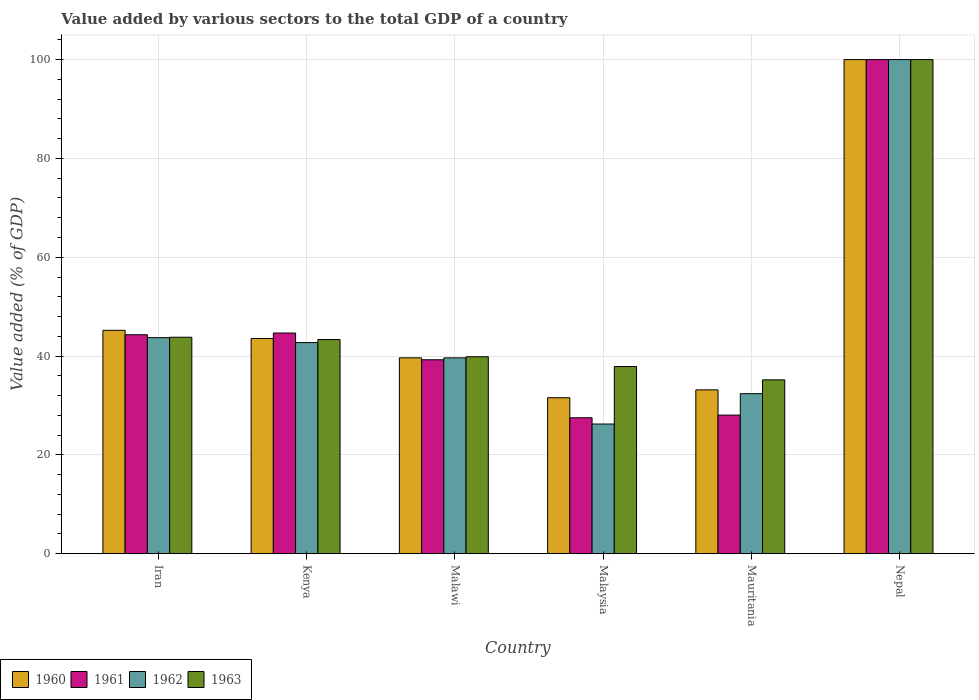How many different coloured bars are there?
Provide a short and direct response. 4. Are the number of bars on each tick of the X-axis equal?
Your answer should be very brief. Yes. What is the label of the 2nd group of bars from the left?
Give a very brief answer. Kenya. In how many cases, is the number of bars for a given country not equal to the number of legend labels?
Offer a terse response. 0. What is the value added by various sectors to the total GDP in 1960 in Mauritania?
Ensure brevity in your answer.  33.17. Across all countries, what is the maximum value added by various sectors to the total GDP in 1960?
Make the answer very short. 100. Across all countries, what is the minimum value added by various sectors to the total GDP in 1960?
Ensure brevity in your answer.  31.57. In which country was the value added by various sectors to the total GDP in 1963 maximum?
Your response must be concise. Nepal. In which country was the value added by various sectors to the total GDP in 1961 minimum?
Your response must be concise. Malaysia. What is the total value added by various sectors to the total GDP in 1961 in the graph?
Give a very brief answer. 283.82. What is the difference between the value added by various sectors to the total GDP in 1962 in Kenya and that in Mauritania?
Give a very brief answer. 10.34. What is the difference between the value added by various sectors to the total GDP in 1960 in Iran and the value added by various sectors to the total GDP in 1962 in Nepal?
Offer a terse response. -54.79. What is the average value added by various sectors to the total GDP in 1961 per country?
Give a very brief answer. 47.3. What is the difference between the value added by various sectors to the total GDP of/in 1962 and value added by various sectors to the total GDP of/in 1963 in Iran?
Offer a terse response. -0.08. What is the ratio of the value added by various sectors to the total GDP in 1962 in Iran to that in Malaysia?
Provide a short and direct response. 1.67. Is the difference between the value added by various sectors to the total GDP in 1962 in Kenya and Mauritania greater than the difference between the value added by various sectors to the total GDP in 1963 in Kenya and Mauritania?
Your response must be concise. Yes. What is the difference between the highest and the second highest value added by various sectors to the total GDP in 1963?
Provide a short and direct response. -0.46. What is the difference between the highest and the lowest value added by various sectors to the total GDP in 1962?
Give a very brief answer. 73.75. In how many countries, is the value added by various sectors to the total GDP in 1963 greater than the average value added by various sectors to the total GDP in 1963 taken over all countries?
Provide a short and direct response. 1. What does the 2nd bar from the right in Nepal represents?
Your answer should be very brief. 1962. Are all the bars in the graph horizontal?
Keep it short and to the point. No. Does the graph contain any zero values?
Give a very brief answer. No. Does the graph contain grids?
Give a very brief answer. Yes. Where does the legend appear in the graph?
Make the answer very short. Bottom left. What is the title of the graph?
Your response must be concise. Value added by various sectors to the total GDP of a country. Does "1962" appear as one of the legend labels in the graph?
Make the answer very short. Yes. What is the label or title of the Y-axis?
Offer a very short reply. Value added (% of GDP). What is the Value added (% of GDP) of 1960 in Iran?
Your answer should be very brief. 45.21. What is the Value added (% of GDP) in 1961 in Iran?
Ensure brevity in your answer.  44.32. What is the Value added (% of GDP) of 1962 in Iran?
Give a very brief answer. 43.73. What is the Value added (% of GDP) in 1963 in Iran?
Offer a terse response. 43.81. What is the Value added (% of GDP) of 1960 in Kenya?
Provide a short and direct response. 43.56. What is the Value added (% of GDP) of 1961 in Kenya?
Your answer should be compact. 44.67. What is the Value added (% of GDP) of 1962 in Kenya?
Provide a short and direct response. 42.73. What is the Value added (% of GDP) of 1963 in Kenya?
Your answer should be compact. 43.35. What is the Value added (% of GDP) of 1960 in Malawi?
Give a very brief answer. 39.64. What is the Value added (% of GDP) in 1961 in Malawi?
Your answer should be compact. 39.25. What is the Value added (% of GDP) in 1962 in Malawi?
Your response must be concise. 39.64. What is the Value added (% of GDP) in 1963 in Malawi?
Offer a terse response. 39.86. What is the Value added (% of GDP) in 1960 in Malaysia?
Your response must be concise. 31.57. What is the Value added (% of GDP) of 1961 in Malaysia?
Your answer should be very brief. 27.52. What is the Value added (% of GDP) in 1962 in Malaysia?
Your response must be concise. 26.25. What is the Value added (% of GDP) in 1963 in Malaysia?
Make the answer very short. 37.89. What is the Value added (% of GDP) of 1960 in Mauritania?
Your answer should be compact. 33.17. What is the Value added (% of GDP) of 1961 in Mauritania?
Offer a terse response. 28.06. What is the Value added (% of GDP) of 1962 in Mauritania?
Your response must be concise. 32.4. What is the Value added (% of GDP) of 1963 in Mauritania?
Offer a very short reply. 35.19. What is the Value added (% of GDP) in 1962 in Nepal?
Your answer should be very brief. 100. Across all countries, what is the maximum Value added (% of GDP) in 1960?
Make the answer very short. 100. Across all countries, what is the maximum Value added (% of GDP) in 1961?
Keep it short and to the point. 100. Across all countries, what is the minimum Value added (% of GDP) in 1960?
Your answer should be compact. 31.57. Across all countries, what is the minimum Value added (% of GDP) of 1961?
Keep it short and to the point. 27.52. Across all countries, what is the minimum Value added (% of GDP) in 1962?
Provide a short and direct response. 26.25. Across all countries, what is the minimum Value added (% of GDP) of 1963?
Give a very brief answer. 35.19. What is the total Value added (% of GDP) of 1960 in the graph?
Provide a succinct answer. 293.16. What is the total Value added (% of GDP) in 1961 in the graph?
Offer a terse response. 283.82. What is the total Value added (% of GDP) of 1962 in the graph?
Keep it short and to the point. 284.74. What is the total Value added (% of GDP) in 1963 in the graph?
Give a very brief answer. 300.1. What is the difference between the Value added (% of GDP) in 1960 in Iran and that in Kenya?
Make the answer very short. 1.65. What is the difference between the Value added (% of GDP) in 1961 in Iran and that in Kenya?
Make the answer very short. -0.35. What is the difference between the Value added (% of GDP) in 1963 in Iran and that in Kenya?
Give a very brief answer. 0.46. What is the difference between the Value added (% of GDP) in 1960 in Iran and that in Malawi?
Make the answer very short. 5.57. What is the difference between the Value added (% of GDP) in 1961 in Iran and that in Malawi?
Provide a succinct answer. 5.07. What is the difference between the Value added (% of GDP) of 1962 in Iran and that in Malawi?
Your answer should be compact. 4.09. What is the difference between the Value added (% of GDP) in 1963 in Iran and that in Malawi?
Offer a very short reply. 3.95. What is the difference between the Value added (% of GDP) of 1960 in Iran and that in Malaysia?
Ensure brevity in your answer.  13.64. What is the difference between the Value added (% of GDP) of 1961 in Iran and that in Malaysia?
Provide a succinct answer. 16.8. What is the difference between the Value added (% of GDP) in 1962 in Iran and that in Malaysia?
Give a very brief answer. 17.48. What is the difference between the Value added (% of GDP) of 1963 in Iran and that in Malaysia?
Keep it short and to the point. 5.92. What is the difference between the Value added (% of GDP) of 1960 in Iran and that in Mauritania?
Offer a very short reply. 12.05. What is the difference between the Value added (% of GDP) in 1961 in Iran and that in Mauritania?
Ensure brevity in your answer.  16.26. What is the difference between the Value added (% of GDP) of 1962 in Iran and that in Mauritania?
Offer a terse response. 11.33. What is the difference between the Value added (% of GDP) of 1963 in Iran and that in Mauritania?
Offer a very short reply. 8.62. What is the difference between the Value added (% of GDP) of 1960 in Iran and that in Nepal?
Provide a succinct answer. -54.79. What is the difference between the Value added (% of GDP) of 1961 in Iran and that in Nepal?
Keep it short and to the point. -55.68. What is the difference between the Value added (% of GDP) in 1962 in Iran and that in Nepal?
Make the answer very short. -56.27. What is the difference between the Value added (% of GDP) of 1963 in Iran and that in Nepal?
Offer a very short reply. -56.19. What is the difference between the Value added (% of GDP) of 1960 in Kenya and that in Malawi?
Keep it short and to the point. 3.92. What is the difference between the Value added (% of GDP) of 1961 in Kenya and that in Malawi?
Your answer should be compact. 5.41. What is the difference between the Value added (% of GDP) of 1962 in Kenya and that in Malawi?
Offer a terse response. 3.1. What is the difference between the Value added (% of GDP) of 1963 in Kenya and that in Malawi?
Make the answer very short. 3.49. What is the difference between the Value added (% of GDP) of 1960 in Kenya and that in Malaysia?
Make the answer very short. 11.99. What is the difference between the Value added (% of GDP) in 1961 in Kenya and that in Malaysia?
Your answer should be very brief. 17.15. What is the difference between the Value added (% of GDP) in 1962 in Kenya and that in Malaysia?
Offer a very short reply. 16.48. What is the difference between the Value added (% of GDP) in 1963 in Kenya and that in Malaysia?
Offer a very short reply. 5.46. What is the difference between the Value added (% of GDP) in 1960 in Kenya and that in Mauritania?
Keep it short and to the point. 10.39. What is the difference between the Value added (% of GDP) of 1961 in Kenya and that in Mauritania?
Offer a very short reply. 16.61. What is the difference between the Value added (% of GDP) in 1962 in Kenya and that in Mauritania?
Ensure brevity in your answer.  10.34. What is the difference between the Value added (% of GDP) in 1963 in Kenya and that in Mauritania?
Offer a terse response. 8.16. What is the difference between the Value added (% of GDP) in 1960 in Kenya and that in Nepal?
Give a very brief answer. -56.44. What is the difference between the Value added (% of GDP) of 1961 in Kenya and that in Nepal?
Make the answer very short. -55.33. What is the difference between the Value added (% of GDP) in 1962 in Kenya and that in Nepal?
Your answer should be very brief. -57.27. What is the difference between the Value added (% of GDP) of 1963 in Kenya and that in Nepal?
Provide a succinct answer. -56.65. What is the difference between the Value added (% of GDP) of 1960 in Malawi and that in Malaysia?
Give a very brief answer. 8.07. What is the difference between the Value added (% of GDP) of 1961 in Malawi and that in Malaysia?
Give a very brief answer. 11.73. What is the difference between the Value added (% of GDP) in 1962 in Malawi and that in Malaysia?
Your response must be concise. 13.39. What is the difference between the Value added (% of GDP) of 1963 in Malawi and that in Malaysia?
Offer a terse response. 1.98. What is the difference between the Value added (% of GDP) in 1960 in Malawi and that in Mauritania?
Give a very brief answer. 6.48. What is the difference between the Value added (% of GDP) of 1961 in Malawi and that in Mauritania?
Keep it short and to the point. 11.2. What is the difference between the Value added (% of GDP) in 1962 in Malawi and that in Mauritania?
Your answer should be compact. 7.24. What is the difference between the Value added (% of GDP) in 1963 in Malawi and that in Mauritania?
Your answer should be very brief. 4.67. What is the difference between the Value added (% of GDP) of 1960 in Malawi and that in Nepal?
Your answer should be very brief. -60.36. What is the difference between the Value added (% of GDP) in 1961 in Malawi and that in Nepal?
Keep it short and to the point. -60.75. What is the difference between the Value added (% of GDP) in 1962 in Malawi and that in Nepal?
Your response must be concise. -60.36. What is the difference between the Value added (% of GDP) of 1963 in Malawi and that in Nepal?
Your answer should be compact. -60.14. What is the difference between the Value added (% of GDP) in 1960 in Malaysia and that in Mauritania?
Your response must be concise. -1.59. What is the difference between the Value added (% of GDP) of 1961 in Malaysia and that in Mauritania?
Ensure brevity in your answer.  -0.54. What is the difference between the Value added (% of GDP) in 1962 in Malaysia and that in Mauritania?
Ensure brevity in your answer.  -6.15. What is the difference between the Value added (% of GDP) of 1963 in Malaysia and that in Mauritania?
Offer a terse response. 2.7. What is the difference between the Value added (% of GDP) of 1960 in Malaysia and that in Nepal?
Provide a succinct answer. -68.43. What is the difference between the Value added (% of GDP) of 1961 in Malaysia and that in Nepal?
Give a very brief answer. -72.48. What is the difference between the Value added (% of GDP) in 1962 in Malaysia and that in Nepal?
Ensure brevity in your answer.  -73.75. What is the difference between the Value added (% of GDP) in 1963 in Malaysia and that in Nepal?
Offer a terse response. -62.11. What is the difference between the Value added (% of GDP) in 1960 in Mauritania and that in Nepal?
Provide a succinct answer. -66.83. What is the difference between the Value added (% of GDP) of 1961 in Mauritania and that in Nepal?
Provide a short and direct response. -71.94. What is the difference between the Value added (% of GDP) of 1962 in Mauritania and that in Nepal?
Ensure brevity in your answer.  -67.6. What is the difference between the Value added (% of GDP) of 1963 in Mauritania and that in Nepal?
Offer a very short reply. -64.81. What is the difference between the Value added (% of GDP) of 1960 in Iran and the Value added (% of GDP) of 1961 in Kenya?
Offer a terse response. 0.55. What is the difference between the Value added (% of GDP) in 1960 in Iran and the Value added (% of GDP) in 1962 in Kenya?
Your response must be concise. 2.48. What is the difference between the Value added (% of GDP) in 1960 in Iran and the Value added (% of GDP) in 1963 in Kenya?
Your answer should be compact. 1.86. What is the difference between the Value added (% of GDP) in 1961 in Iran and the Value added (% of GDP) in 1962 in Kenya?
Ensure brevity in your answer.  1.59. What is the difference between the Value added (% of GDP) of 1961 in Iran and the Value added (% of GDP) of 1963 in Kenya?
Make the answer very short. 0.97. What is the difference between the Value added (% of GDP) in 1962 in Iran and the Value added (% of GDP) in 1963 in Kenya?
Make the answer very short. 0.38. What is the difference between the Value added (% of GDP) in 1960 in Iran and the Value added (% of GDP) in 1961 in Malawi?
Offer a terse response. 5.96. What is the difference between the Value added (% of GDP) in 1960 in Iran and the Value added (% of GDP) in 1962 in Malawi?
Make the answer very short. 5.58. What is the difference between the Value added (% of GDP) in 1960 in Iran and the Value added (% of GDP) in 1963 in Malawi?
Give a very brief answer. 5.35. What is the difference between the Value added (% of GDP) of 1961 in Iran and the Value added (% of GDP) of 1962 in Malawi?
Keep it short and to the point. 4.68. What is the difference between the Value added (% of GDP) of 1961 in Iran and the Value added (% of GDP) of 1963 in Malawi?
Your answer should be compact. 4.46. What is the difference between the Value added (% of GDP) of 1962 in Iran and the Value added (% of GDP) of 1963 in Malawi?
Provide a succinct answer. 3.87. What is the difference between the Value added (% of GDP) of 1960 in Iran and the Value added (% of GDP) of 1961 in Malaysia?
Provide a short and direct response. 17.7. What is the difference between the Value added (% of GDP) of 1960 in Iran and the Value added (% of GDP) of 1962 in Malaysia?
Provide a short and direct response. 18.96. What is the difference between the Value added (% of GDP) of 1960 in Iran and the Value added (% of GDP) of 1963 in Malaysia?
Give a very brief answer. 7.33. What is the difference between the Value added (% of GDP) of 1961 in Iran and the Value added (% of GDP) of 1962 in Malaysia?
Your answer should be very brief. 18.07. What is the difference between the Value added (% of GDP) in 1961 in Iran and the Value added (% of GDP) in 1963 in Malaysia?
Provide a short and direct response. 6.43. What is the difference between the Value added (% of GDP) in 1962 in Iran and the Value added (% of GDP) in 1963 in Malaysia?
Your answer should be very brief. 5.84. What is the difference between the Value added (% of GDP) in 1960 in Iran and the Value added (% of GDP) in 1961 in Mauritania?
Your response must be concise. 17.16. What is the difference between the Value added (% of GDP) in 1960 in Iran and the Value added (% of GDP) in 1962 in Mauritania?
Ensure brevity in your answer.  12.82. What is the difference between the Value added (% of GDP) of 1960 in Iran and the Value added (% of GDP) of 1963 in Mauritania?
Your response must be concise. 10.02. What is the difference between the Value added (% of GDP) of 1961 in Iran and the Value added (% of GDP) of 1962 in Mauritania?
Keep it short and to the point. 11.92. What is the difference between the Value added (% of GDP) in 1961 in Iran and the Value added (% of GDP) in 1963 in Mauritania?
Make the answer very short. 9.13. What is the difference between the Value added (% of GDP) in 1962 in Iran and the Value added (% of GDP) in 1963 in Mauritania?
Make the answer very short. 8.54. What is the difference between the Value added (% of GDP) in 1960 in Iran and the Value added (% of GDP) in 1961 in Nepal?
Give a very brief answer. -54.79. What is the difference between the Value added (% of GDP) in 1960 in Iran and the Value added (% of GDP) in 1962 in Nepal?
Your response must be concise. -54.79. What is the difference between the Value added (% of GDP) in 1960 in Iran and the Value added (% of GDP) in 1963 in Nepal?
Offer a terse response. -54.79. What is the difference between the Value added (% of GDP) in 1961 in Iran and the Value added (% of GDP) in 1962 in Nepal?
Ensure brevity in your answer.  -55.68. What is the difference between the Value added (% of GDP) of 1961 in Iran and the Value added (% of GDP) of 1963 in Nepal?
Keep it short and to the point. -55.68. What is the difference between the Value added (% of GDP) of 1962 in Iran and the Value added (% of GDP) of 1963 in Nepal?
Give a very brief answer. -56.27. What is the difference between the Value added (% of GDP) of 1960 in Kenya and the Value added (% of GDP) of 1961 in Malawi?
Keep it short and to the point. 4.31. What is the difference between the Value added (% of GDP) in 1960 in Kenya and the Value added (% of GDP) in 1962 in Malawi?
Offer a terse response. 3.92. What is the difference between the Value added (% of GDP) of 1960 in Kenya and the Value added (% of GDP) of 1963 in Malawi?
Give a very brief answer. 3.7. What is the difference between the Value added (% of GDP) of 1961 in Kenya and the Value added (% of GDP) of 1962 in Malawi?
Give a very brief answer. 5.03. What is the difference between the Value added (% of GDP) in 1961 in Kenya and the Value added (% of GDP) in 1963 in Malawi?
Offer a very short reply. 4.8. What is the difference between the Value added (% of GDP) of 1962 in Kenya and the Value added (% of GDP) of 1963 in Malawi?
Keep it short and to the point. 2.87. What is the difference between the Value added (% of GDP) in 1960 in Kenya and the Value added (% of GDP) in 1961 in Malaysia?
Ensure brevity in your answer.  16.04. What is the difference between the Value added (% of GDP) in 1960 in Kenya and the Value added (% of GDP) in 1962 in Malaysia?
Provide a short and direct response. 17.31. What is the difference between the Value added (% of GDP) of 1960 in Kenya and the Value added (% of GDP) of 1963 in Malaysia?
Your answer should be compact. 5.67. What is the difference between the Value added (% of GDP) in 1961 in Kenya and the Value added (% of GDP) in 1962 in Malaysia?
Ensure brevity in your answer.  18.42. What is the difference between the Value added (% of GDP) of 1961 in Kenya and the Value added (% of GDP) of 1963 in Malaysia?
Keep it short and to the point. 6.78. What is the difference between the Value added (% of GDP) in 1962 in Kenya and the Value added (% of GDP) in 1963 in Malaysia?
Your answer should be compact. 4.84. What is the difference between the Value added (% of GDP) of 1960 in Kenya and the Value added (% of GDP) of 1961 in Mauritania?
Ensure brevity in your answer.  15.5. What is the difference between the Value added (% of GDP) of 1960 in Kenya and the Value added (% of GDP) of 1962 in Mauritania?
Make the answer very short. 11.16. What is the difference between the Value added (% of GDP) of 1960 in Kenya and the Value added (% of GDP) of 1963 in Mauritania?
Keep it short and to the point. 8.37. What is the difference between the Value added (% of GDP) of 1961 in Kenya and the Value added (% of GDP) of 1962 in Mauritania?
Your answer should be compact. 12.27. What is the difference between the Value added (% of GDP) of 1961 in Kenya and the Value added (% of GDP) of 1963 in Mauritania?
Offer a very short reply. 9.48. What is the difference between the Value added (% of GDP) in 1962 in Kenya and the Value added (% of GDP) in 1963 in Mauritania?
Ensure brevity in your answer.  7.54. What is the difference between the Value added (% of GDP) of 1960 in Kenya and the Value added (% of GDP) of 1961 in Nepal?
Offer a very short reply. -56.44. What is the difference between the Value added (% of GDP) in 1960 in Kenya and the Value added (% of GDP) in 1962 in Nepal?
Ensure brevity in your answer.  -56.44. What is the difference between the Value added (% of GDP) in 1960 in Kenya and the Value added (% of GDP) in 1963 in Nepal?
Make the answer very short. -56.44. What is the difference between the Value added (% of GDP) of 1961 in Kenya and the Value added (% of GDP) of 1962 in Nepal?
Ensure brevity in your answer.  -55.33. What is the difference between the Value added (% of GDP) of 1961 in Kenya and the Value added (% of GDP) of 1963 in Nepal?
Offer a terse response. -55.33. What is the difference between the Value added (% of GDP) of 1962 in Kenya and the Value added (% of GDP) of 1963 in Nepal?
Provide a short and direct response. -57.27. What is the difference between the Value added (% of GDP) of 1960 in Malawi and the Value added (% of GDP) of 1961 in Malaysia?
Make the answer very short. 12.13. What is the difference between the Value added (% of GDP) in 1960 in Malawi and the Value added (% of GDP) in 1962 in Malaysia?
Offer a very short reply. 13.39. What is the difference between the Value added (% of GDP) of 1960 in Malawi and the Value added (% of GDP) of 1963 in Malaysia?
Offer a very short reply. 1.76. What is the difference between the Value added (% of GDP) in 1961 in Malawi and the Value added (% of GDP) in 1962 in Malaysia?
Offer a terse response. 13. What is the difference between the Value added (% of GDP) of 1961 in Malawi and the Value added (% of GDP) of 1963 in Malaysia?
Make the answer very short. 1.37. What is the difference between the Value added (% of GDP) in 1962 in Malawi and the Value added (% of GDP) in 1963 in Malaysia?
Provide a succinct answer. 1.75. What is the difference between the Value added (% of GDP) of 1960 in Malawi and the Value added (% of GDP) of 1961 in Mauritania?
Provide a succinct answer. 11.59. What is the difference between the Value added (% of GDP) in 1960 in Malawi and the Value added (% of GDP) in 1962 in Mauritania?
Provide a succinct answer. 7.25. What is the difference between the Value added (% of GDP) in 1960 in Malawi and the Value added (% of GDP) in 1963 in Mauritania?
Your answer should be compact. 4.45. What is the difference between the Value added (% of GDP) in 1961 in Malawi and the Value added (% of GDP) in 1962 in Mauritania?
Provide a short and direct response. 6.86. What is the difference between the Value added (% of GDP) of 1961 in Malawi and the Value added (% of GDP) of 1963 in Mauritania?
Give a very brief answer. 4.06. What is the difference between the Value added (% of GDP) of 1962 in Malawi and the Value added (% of GDP) of 1963 in Mauritania?
Offer a terse response. 4.45. What is the difference between the Value added (% of GDP) in 1960 in Malawi and the Value added (% of GDP) in 1961 in Nepal?
Your answer should be compact. -60.36. What is the difference between the Value added (% of GDP) of 1960 in Malawi and the Value added (% of GDP) of 1962 in Nepal?
Provide a succinct answer. -60.36. What is the difference between the Value added (% of GDP) in 1960 in Malawi and the Value added (% of GDP) in 1963 in Nepal?
Provide a short and direct response. -60.36. What is the difference between the Value added (% of GDP) in 1961 in Malawi and the Value added (% of GDP) in 1962 in Nepal?
Your answer should be compact. -60.75. What is the difference between the Value added (% of GDP) of 1961 in Malawi and the Value added (% of GDP) of 1963 in Nepal?
Offer a very short reply. -60.75. What is the difference between the Value added (% of GDP) in 1962 in Malawi and the Value added (% of GDP) in 1963 in Nepal?
Your response must be concise. -60.36. What is the difference between the Value added (% of GDP) of 1960 in Malaysia and the Value added (% of GDP) of 1961 in Mauritania?
Offer a terse response. 3.51. What is the difference between the Value added (% of GDP) in 1960 in Malaysia and the Value added (% of GDP) in 1962 in Mauritania?
Ensure brevity in your answer.  -0.82. What is the difference between the Value added (% of GDP) of 1960 in Malaysia and the Value added (% of GDP) of 1963 in Mauritania?
Your answer should be compact. -3.62. What is the difference between the Value added (% of GDP) of 1961 in Malaysia and the Value added (% of GDP) of 1962 in Mauritania?
Ensure brevity in your answer.  -4.88. What is the difference between the Value added (% of GDP) in 1961 in Malaysia and the Value added (% of GDP) in 1963 in Mauritania?
Provide a short and direct response. -7.67. What is the difference between the Value added (% of GDP) in 1962 in Malaysia and the Value added (% of GDP) in 1963 in Mauritania?
Your answer should be very brief. -8.94. What is the difference between the Value added (% of GDP) of 1960 in Malaysia and the Value added (% of GDP) of 1961 in Nepal?
Keep it short and to the point. -68.43. What is the difference between the Value added (% of GDP) in 1960 in Malaysia and the Value added (% of GDP) in 1962 in Nepal?
Give a very brief answer. -68.43. What is the difference between the Value added (% of GDP) in 1960 in Malaysia and the Value added (% of GDP) in 1963 in Nepal?
Your answer should be compact. -68.43. What is the difference between the Value added (% of GDP) of 1961 in Malaysia and the Value added (% of GDP) of 1962 in Nepal?
Offer a very short reply. -72.48. What is the difference between the Value added (% of GDP) of 1961 in Malaysia and the Value added (% of GDP) of 1963 in Nepal?
Offer a terse response. -72.48. What is the difference between the Value added (% of GDP) of 1962 in Malaysia and the Value added (% of GDP) of 1963 in Nepal?
Ensure brevity in your answer.  -73.75. What is the difference between the Value added (% of GDP) of 1960 in Mauritania and the Value added (% of GDP) of 1961 in Nepal?
Offer a terse response. -66.83. What is the difference between the Value added (% of GDP) in 1960 in Mauritania and the Value added (% of GDP) in 1962 in Nepal?
Your answer should be very brief. -66.83. What is the difference between the Value added (% of GDP) of 1960 in Mauritania and the Value added (% of GDP) of 1963 in Nepal?
Provide a short and direct response. -66.83. What is the difference between the Value added (% of GDP) of 1961 in Mauritania and the Value added (% of GDP) of 1962 in Nepal?
Offer a very short reply. -71.94. What is the difference between the Value added (% of GDP) in 1961 in Mauritania and the Value added (% of GDP) in 1963 in Nepal?
Keep it short and to the point. -71.94. What is the difference between the Value added (% of GDP) in 1962 in Mauritania and the Value added (% of GDP) in 1963 in Nepal?
Give a very brief answer. -67.6. What is the average Value added (% of GDP) in 1960 per country?
Offer a very short reply. 48.86. What is the average Value added (% of GDP) of 1961 per country?
Keep it short and to the point. 47.3. What is the average Value added (% of GDP) in 1962 per country?
Your answer should be very brief. 47.46. What is the average Value added (% of GDP) of 1963 per country?
Your answer should be very brief. 50.02. What is the difference between the Value added (% of GDP) of 1960 and Value added (% of GDP) of 1961 in Iran?
Make the answer very short. 0.89. What is the difference between the Value added (% of GDP) in 1960 and Value added (% of GDP) in 1962 in Iran?
Provide a succinct answer. 1.48. What is the difference between the Value added (% of GDP) of 1960 and Value added (% of GDP) of 1963 in Iran?
Your answer should be very brief. 1.4. What is the difference between the Value added (% of GDP) of 1961 and Value added (% of GDP) of 1962 in Iran?
Your response must be concise. 0.59. What is the difference between the Value added (% of GDP) of 1961 and Value added (% of GDP) of 1963 in Iran?
Provide a short and direct response. 0.51. What is the difference between the Value added (% of GDP) in 1962 and Value added (% of GDP) in 1963 in Iran?
Ensure brevity in your answer.  -0.08. What is the difference between the Value added (% of GDP) in 1960 and Value added (% of GDP) in 1961 in Kenya?
Offer a terse response. -1.11. What is the difference between the Value added (% of GDP) in 1960 and Value added (% of GDP) in 1962 in Kenya?
Provide a short and direct response. 0.83. What is the difference between the Value added (% of GDP) in 1960 and Value added (% of GDP) in 1963 in Kenya?
Offer a very short reply. 0.21. What is the difference between the Value added (% of GDP) of 1961 and Value added (% of GDP) of 1962 in Kenya?
Offer a very short reply. 1.94. What is the difference between the Value added (% of GDP) in 1961 and Value added (% of GDP) in 1963 in Kenya?
Make the answer very short. 1.32. What is the difference between the Value added (% of GDP) of 1962 and Value added (% of GDP) of 1963 in Kenya?
Your answer should be compact. -0.62. What is the difference between the Value added (% of GDP) of 1960 and Value added (% of GDP) of 1961 in Malawi?
Give a very brief answer. 0.39. What is the difference between the Value added (% of GDP) in 1960 and Value added (% of GDP) in 1962 in Malawi?
Provide a succinct answer. 0.01. What is the difference between the Value added (% of GDP) in 1960 and Value added (% of GDP) in 1963 in Malawi?
Offer a terse response. -0.22. What is the difference between the Value added (% of GDP) in 1961 and Value added (% of GDP) in 1962 in Malawi?
Provide a short and direct response. -0.38. What is the difference between the Value added (% of GDP) of 1961 and Value added (% of GDP) of 1963 in Malawi?
Provide a succinct answer. -0.61. What is the difference between the Value added (% of GDP) of 1962 and Value added (% of GDP) of 1963 in Malawi?
Your response must be concise. -0.23. What is the difference between the Value added (% of GDP) of 1960 and Value added (% of GDP) of 1961 in Malaysia?
Your response must be concise. 4.05. What is the difference between the Value added (% of GDP) in 1960 and Value added (% of GDP) in 1962 in Malaysia?
Your response must be concise. 5.32. What is the difference between the Value added (% of GDP) in 1960 and Value added (% of GDP) in 1963 in Malaysia?
Give a very brief answer. -6.31. What is the difference between the Value added (% of GDP) of 1961 and Value added (% of GDP) of 1962 in Malaysia?
Your answer should be very brief. 1.27. What is the difference between the Value added (% of GDP) in 1961 and Value added (% of GDP) in 1963 in Malaysia?
Offer a terse response. -10.37. What is the difference between the Value added (% of GDP) in 1962 and Value added (% of GDP) in 1963 in Malaysia?
Your response must be concise. -11.64. What is the difference between the Value added (% of GDP) in 1960 and Value added (% of GDP) in 1961 in Mauritania?
Offer a terse response. 5.11. What is the difference between the Value added (% of GDP) in 1960 and Value added (% of GDP) in 1962 in Mauritania?
Provide a short and direct response. 0.77. What is the difference between the Value added (% of GDP) of 1960 and Value added (% of GDP) of 1963 in Mauritania?
Give a very brief answer. -2.02. What is the difference between the Value added (% of GDP) in 1961 and Value added (% of GDP) in 1962 in Mauritania?
Offer a terse response. -4.34. What is the difference between the Value added (% of GDP) of 1961 and Value added (% of GDP) of 1963 in Mauritania?
Your answer should be very brief. -7.13. What is the difference between the Value added (% of GDP) in 1962 and Value added (% of GDP) in 1963 in Mauritania?
Make the answer very short. -2.79. What is the difference between the Value added (% of GDP) of 1960 and Value added (% of GDP) of 1961 in Nepal?
Offer a very short reply. 0. What is the difference between the Value added (% of GDP) of 1961 and Value added (% of GDP) of 1962 in Nepal?
Keep it short and to the point. 0. What is the difference between the Value added (% of GDP) in 1961 and Value added (% of GDP) in 1963 in Nepal?
Offer a terse response. 0. What is the ratio of the Value added (% of GDP) of 1960 in Iran to that in Kenya?
Your answer should be compact. 1.04. What is the ratio of the Value added (% of GDP) in 1962 in Iran to that in Kenya?
Give a very brief answer. 1.02. What is the ratio of the Value added (% of GDP) in 1963 in Iran to that in Kenya?
Ensure brevity in your answer.  1.01. What is the ratio of the Value added (% of GDP) of 1960 in Iran to that in Malawi?
Offer a terse response. 1.14. What is the ratio of the Value added (% of GDP) in 1961 in Iran to that in Malawi?
Give a very brief answer. 1.13. What is the ratio of the Value added (% of GDP) in 1962 in Iran to that in Malawi?
Your answer should be compact. 1.1. What is the ratio of the Value added (% of GDP) in 1963 in Iran to that in Malawi?
Provide a succinct answer. 1.1. What is the ratio of the Value added (% of GDP) of 1960 in Iran to that in Malaysia?
Give a very brief answer. 1.43. What is the ratio of the Value added (% of GDP) of 1961 in Iran to that in Malaysia?
Provide a succinct answer. 1.61. What is the ratio of the Value added (% of GDP) in 1962 in Iran to that in Malaysia?
Provide a short and direct response. 1.67. What is the ratio of the Value added (% of GDP) in 1963 in Iran to that in Malaysia?
Give a very brief answer. 1.16. What is the ratio of the Value added (% of GDP) in 1960 in Iran to that in Mauritania?
Provide a succinct answer. 1.36. What is the ratio of the Value added (% of GDP) of 1961 in Iran to that in Mauritania?
Offer a terse response. 1.58. What is the ratio of the Value added (% of GDP) in 1962 in Iran to that in Mauritania?
Your response must be concise. 1.35. What is the ratio of the Value added (% of GDP) of 1963 in Iran to that in Mauritania?
Your answer should be compact. 1.25. What is the ratio of the Value added (% of GDP) in 1960 in Iran to that in Nepal?
Ensure brevity in your answer.  0.45. What is the ratio of the Value added (% of GDP) in 1961 in Iran to that in Nepal?
Make the answer very short. 0.44. What is the ratio of the Value added (% of GDP) of 1962 in Iran to that in Nepal?
Keep it short and to the point. 0.44. What is the ratio of the Value added (% of GDP) of 1963 in Iran to that in Nepal?
Keep it short and to the point. 0.44. What is the ratio of the Value added (% of GDP) in 1960 in Kenya to that in Malawi?
Make the answer very short. 1.1. What is the ratio of the Value added (% of GDP) in 1961 in Kenya to that in Malawi?
Provide a succinct answer. 1.14. What is the ratio of the Value added (% of GDP) of 1962 in Kenya to that in Malawi?
Keep it short and to the point. 1.08. What is the ratio of the Value added (% of GDP) in 1963 in Kenya to that in Malawi?
Keep it short and to the point. 1.09. What is the ratio of the Value added (% of GDP) of 1960 in Kenya to that in Malaysia?
Your answer should be very brief. 1.38. What is the ratio of the Value added (% of GDP) in 1961 in Kenya to that in Malaysia?
Provide a succinct answer. 1.62. What is the ratio of the Value added (% of GDP) in 1962 in Kenya to that in Malaysia?
Make the answer very short. 1.63. What is the ratio of the Value added (% of GDP) of 1963 in Kenya to that in Malaysia?
Offer a very short reply. 1.14. What is the ratio of the Value added (% of GDP) of 1960 in Kenya to that in Mauritania?
Offer a very short reply. 1.31. What is the ratio of the Value added (% of GDP) in 1961 in Kenya to that in Mauritania?
Provide a succinct answer. 1.59. What is the ratio of the Value added (% of GDP) in 1962 in Kenya to that in Mauritania?
Give a very brief answer. 1.32. What is the ratio of the Value added (% of GDP) of 1963 in Kenya to that in Mauritania?
Your answer should be very brief. 1.23. What is the ratio of the Value added (% of GDP) of 1960 in Kenya to that in Nepal?
Give a very brief answer. 0.44. What is the ratio of the Value added (% of GDP) of 1961 in Kenya to that in Nepal?
Ensure brevity in your answer.  0.45. What is the ratio of the Value added (% of GDP) in 1962 in Kenya to that in Nepal?
Keep it short and to the point. 0.43. What is the ratio of the Value added (% of GDP) in 1963 in Kenya to that in Nepal?
Provide a succinct answer. 0.43. What is the ratio of the Value added (% of GDP) of 1960 in Malawi to that in Malaysia?
Provide a succinct answer. 1.26. What is the ratio of the Value added (% of GDP) in 1961 in Malawi to that in Malaysia?
Ensure brevity in your answer.  1.43. What is the ratio of the Value added (% of GDP) of 1962 in Malawi to that in Malaysia?
Give a very brief answer. 1.51. What is the ratio of the Value added (% of GDP) of 1963 in Malawi to that in Malaysia?
Your answer should be very brief. 1.05. What is the ratio of the Value added (% of GDP) of 1960 in Malawi to that in Mauritania?
Offer a terse response. 1.2. What is the ratio of the Value added (% of GDP) of 1961 in Malawi to that in Mauritania?
Provide a short and direct response. 1.4. What is the ratio of the Value added (% of GDP) in 1962 in Malawi to that in Mauritania?
Your answer should be very brief. 1.22. What is the ratio of the Value added (% of GDP) of 1963 in Malawi to that in Mauritania?
Ensure brevity in your answer.  1.13. What is the ratio of the Value added (% of GDP) in 1960 in Malawi to that in Nepal?
Offer a terse response. 0.4. What is the ratio of the Value added (% of GDP) of 1961 in Malawi to that in Nepal?
Make the answer very short. 0.39. What is the ratio of the Value added (% of GDP) of 1962 in Malawi to that in Nepal?
Provide a succinct answer. 0.4. What is the ratio of the Value added (% of GDP) of 1963 in Malawi to that in Nepal?
Offer a very short reply. 0.4. What is the ratio of the Value added (% of GDP) of 1960 in Malaysia to that in Mauritania?
Provide a short and direct response. 0.95. What is the ratio of the Value added (% of GDP) of 1961 in Malaysia to that in Mauritania?
Your response must be concise. 0.98. What is the ratio of the Value added (% of GDP) in 1962 in Malaysia to that in Mauritania?
Give a very brief answer. 0.81. What is the ratio of the Value added (% of GDP) in 1963 in Malaysia to that in Mauritania?
Ensure brevity in your answer.  1.08. What is the ratio of the Value added (% of GDP) in 1960 in Malaysia to that in Nepal?
Offer a very short reply. 0.32. What is the ratio of the Value added (% of GDP) of 1961 in Malaysia to that in Nepal?
Provide a short and direct response. 0.28. What is the ratio of the Value added (% of GDP) of 1962 in Malaysia to that in Nepal?
Provide a succinct answer. 0.26. What is the ratio of the Value added (% of GDP) of 1963 in Malaysia to that in Nepal?
Your answer should be compact. 0.38. What is the ratio of the Value added (% of GDP) in 1960 in Mauritania to that in Nepal?
Make the answer very short. 0.33. What is the ratio of the Value added (% of GDP) in 1961 in Mauritania to that in Nepal?
Offer a terse response. 0.28. What is the ratio of the Value added (% of GDP) in 1962 in Mauritania to that in Nepal?
Make the answer very short. 0.32. What is the ratio of the Value added (% of GDP) of 1963 in Mauritania to that in Nepal?
Give a very brief answer. 0.35. What is the difference between the highest and the second highest Value added (% of GDP) in 1960?
Keep it short and to the point. 54.79. What is the difference between the highest and the second highest Value added (% of GDP) in 1961?
Offer a terse response. 55.33. What is the difference between the highest and the second highest Value added (% of GDP) in 1962?
Offer a terse response. 56.27. What is the difference between the highest and the second highest Value added (% of GDP) of 1963?
Your answer should be compact. 56.19. What is the difference between the highest and the lowest Value added (% of GDP) in 1960?
Ensure brevity in your answer.  68.43. What is the difference between the highest and the lowest Value added (% of GDP) in 1961?
Give a very brief answer. 72.48. What is the difference between the highest and the lowest Value added (% of GDP) in 1962?
Your answer should be very brief. 73.75. What is the difference between the highest and the lowest Value added (% of GDP) of 1963?
Ensure brevity in your answer.  64.81. 